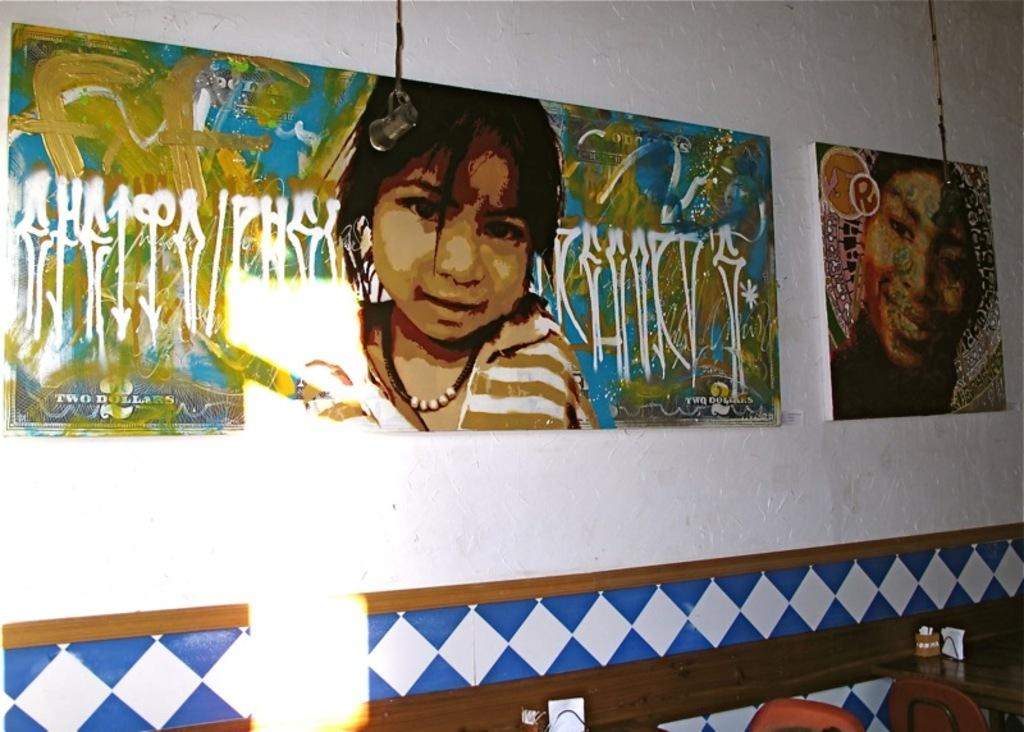What type of furniture is present in the image? There are chairs and tables in the image. What other items can be seen in the image? There are tissue paper stands in the image. What is on the wall in the image? There are boards on the wall in the image. What is depicted on the boards? There are paintings on the boards in the image. Can you see a bird making a curve in the image? There is no bird or curve present in the image. What type of crayon is being used to draw on the paintings in the image? There is no crayon or drawing activity depicted in the image. 